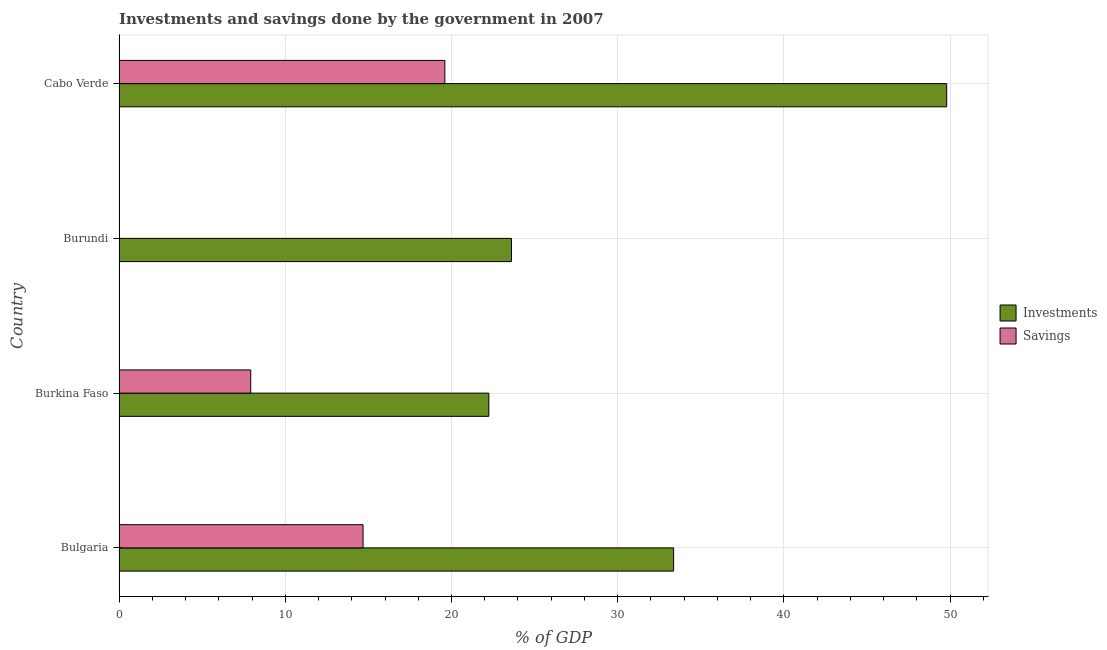How many bars are there on the 2nd tick from the top?
Offer a very short reply. 1. What is the label of the 1st group of bars from the top?
Make the answer very short. Cabo Verde. What is the savings of government in Burkina Faso?
Make the answer very short. 7.92. Across all countries, what is the maximum savings of government?
Give a very brief answer. 19.6. In which country was the savings of government maximum?
Offer a very short reply. Cabo Verde. What is the total savings of government in the graph?
Offer a very short reply. 42.2. What is the difference between the investments of government in Bulgaria and that in Burkina Faso?
Make the answer very short. 11.12. What is the difference between the investments of government in Bulgaria and the savings of government in Burkina Faso?
Offer a terse response. 25.44. What is the average investments of government per country?
Your answer should be very brief. 32.25. What is the difference between the savings of government and investments of government in Bulgaria?
Provide a succinct answer. -18.68. In how many countries, is the investments of government greater than 42 %?
Your response must be concise. 1. What is the ratio of the investments of government in Burkina Faso to that in Burundi?
Offer a very short reply. 0.94. Is the savings of government in Burkina Faso less than that in Cabo Verde?
Your response must be concise. Yes. What is the difference between the highest and the second highest savings of government?
Ensure brevity in your answer.  4.92. What is the difference between the highest and the lowest investments of government?
Ensure brevity in your answer.  27.54. In how many countries, is the investments of government greater than the average investments of government taken over all countries?
Offer a very short reply. 2. How many bars are there?
Your answer should be very brief. 7. How many countries are there in the graph?
Your answer should be compact. 4. Does the graph contain grids?
Give a very brief answer. Yes. What is the title of the graph?
Provide a succinct answer. Investments and savings done by the government in 2007. Does "Non-solid fuel" appear as one of the legend labels in the graph?
Ensure brevity in your answer.  No. What is the label or title of the X-axis?
Your answer should be compact. % of GDP. What is the % of GDP of Investments in Bulgaria?
Your answer should be compact. 33.36. What is the % of GDP of Savings in Bulgaria?
Your answer should be very brief. 14.68. What is the % of GDP of Investments in Burkina Faso?
Provide a short and direct response. 22.25. What is the % of GDP in Savings in Burkina Faso?
Keep it short and to the point. 7.92. What is the % of GDP in Investments in Burundi?
Keep it short and to the point. 23.61. What is the % of GDP of Investments in Cabo Verde?
Offer a very short reply. 49.79. What is the % of GDP of Savings in Cabo Verde?
Give a very brief answer. 19.6. Across all countries, what is the maximum % of GDP in Investments?
Make the answer very short. 49.79. Across all countries, what is the maximum % of GDP of Savings?
Offer a terse response. 19.6. Across all countries, what is the minimum % of GDP of Investments?
Provide a succinct answer. 22.25. Across all countries, what is the minimum % of GDP in Savings?
Your answer should be compact. 0. What is the total % of GDP in Investments in the graph?
Your answer should be very brief. 129.01. What is the total % of GDP in Savings in the graph?
Your answer should be very brief. 42.2. What is the difference between the % of GDP of Investments in Bulgaria and that in Burkina Faso?
Ensure brevity in your answer.  11.12. What is the difference between the % of GDP in Savings in Bulgaria and that in Burkina Faso?
Offer a terse response. 6.76. What is the difference between the % of GDP in Investments in Bulgaria and that in Burundi?
Ensure brevity in your answer.  9.76. What is the difference between the % of GDP in Investments in Bulgaria and that in Cabo Verde?
Your response must be concise. -16.43. What is the difference between the % of GDP of Savings in Bulgaria and that in Cabo Verde?
Give a very brief answer. -4.92. What is the difference between the % of GDP of Investments in Burkina Faso and that in Burundi?
Give a very brief answer. -1.36. What is the difference between the % of GDP of Investments in Burkina Faso and that in Cabo Verde?
Provide a succinct answer. -27.54. What is the difference between the % of GDP in Savings in Burkina Faso and that in Cabo Verde?
Your answer should be compact. -11.68. What is the difference between the % of GDP of Investments in Burundi and that in Cabo Verde?
Make the answer very short. -26.18. What is the difference between the % of GDP in Investments in Bulgaria and the % of GDP in Savings in Burkina Faso?
Provide a short and direct response. 25.44. What is the difference between the % of GDP of Investments in Bulgaria and the % of GDP of Savings in Cabo Verde?
Your answer should be compact. 13.76. What is the difference between the % of GDP in Investments in Burkina Faso and the % of GDP in Savings in Cabo Verde?
Ensure brevity in your answer.  2.65. What is the difference between the % of GDP in Investments in Burundi and the % of GDP in Savings in Cabo Verde?
Your answer should be very brief. 4.01. What is the average % of GDP in Investments per country?
Provide a succinct answer. 32.25. What is the average % of GDP of Savings per country?
Offer a very short reply. 10.55. What is the difference between the % of GDP in Investments and % of GDP in Savings in Bulgaria?
Provide a succinct answer. 18.68. What is the difference between the % of GDP of Investments and % of GDP of Savings in Burkina Faso?
Ensure brevity in your answer.  14.33. What is the difference between the % of GDP in Investments and % of GDP in Savings in Cabo Verde?
Give a very brief answer. 30.19. What is the ratio of the % of GDP of Investments in Bulgaria to that in Burkina Faso?
Give a very brief answer. 1.5. What is the ratio of the % of GDP of Savings in Bulgaria to that in Burkina Faso?
Your answer should be compact. 1.85. What is the ratio of the % of GDP in Investments in Bulgaria to that in Burundi?
Give a very brief answer. 1.41. What is the ratio of the % of GDP in Investments in Bulgaria to that in Cabo Verde?
Provide a succinct answer. 0.67. What is the ratio of the % of GDP of Savings in Bulgaria to that in Cabo Verde?
Give a very brief answer. 0.75. What is the ratio of the % of GDP of Investments in Burkina Faso to that in Burundi?
Provide a short and direct response. 0.94. What is the ratio of the % of GDP in Investments in Burkina Faso to that in Cabo Verde?
Offer a very short reply. 0.45. What is the ratio of the % of GDP in Savings in Burkina Faso to that in Cabo Verde?
Offer a very short reply. 0.4. What is the ratio of the % of GDP of Investments in Burundi to that in Cabo Verde?
Your response must be concise. 0.47. What is the difference between the highest and the second highest % of GDP in Investments?
Your answer should be compact. 16.43. What is the difference between the highest and the second highest % of GDP of Savings?
Offer a very short reply. 4.92. What is the difference between the highest and the lowest % of GDP in Investments?
Your response must be concise. 27.54. What is the difference between the highest and the lowest % of GDP in Savings?
Provide a short and direct response. 19.6. 